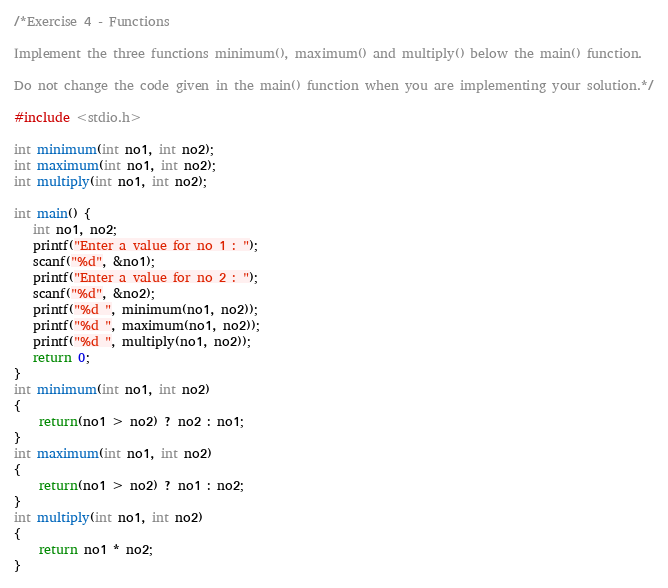<code> <loc_0><loc_0><loc_500><loc_500><_C_>/*Exercise 4 - Functions

Implement the three functions minimum(), maximum() and multiply() below the main() function.

Do not change the code given in the main() function when you are implementing your solution.*/

#include <stdio.h>

int minimum(int no1, int no2);
int maximum(int no1, int no2);
int multiply(int no1, int no2);

int main() {
   int no1, no2;
   printf("Enter a value for no 1 : ");
   scanf("%d", &no1);
   printf("Enter a value for no 2 : ");
   scanf("%d", &no2);
   printf("%d ", minimum(no1, no2));
   printf("%d ", maximum(no1, no2));
   printf("%d ", multiply(no1, no2));
   return 0;
}
int minimum(int no1, int no2)
{
	return(no1 > no2) ? no2 : no1;
}
int maximum(int no1, int no2)
{
	return(no1 > no2) ? no1 : no2;
}
int multiply(int no1, int no2)
{
	return no1 * no2;
}</code> 